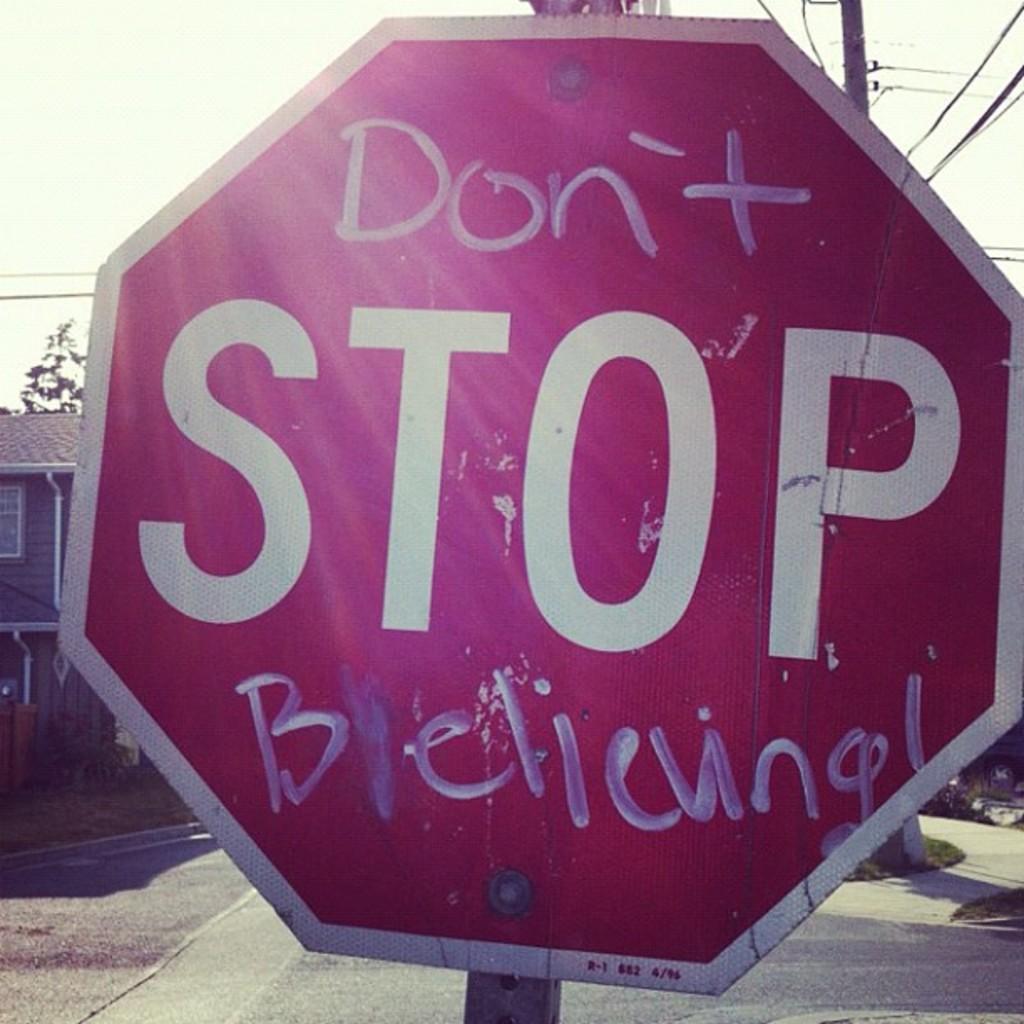Describe this image in one or two sentences. In this image I can see a red colour board and on it I can see something is written. In background I can see a building, a pole and few wires. 